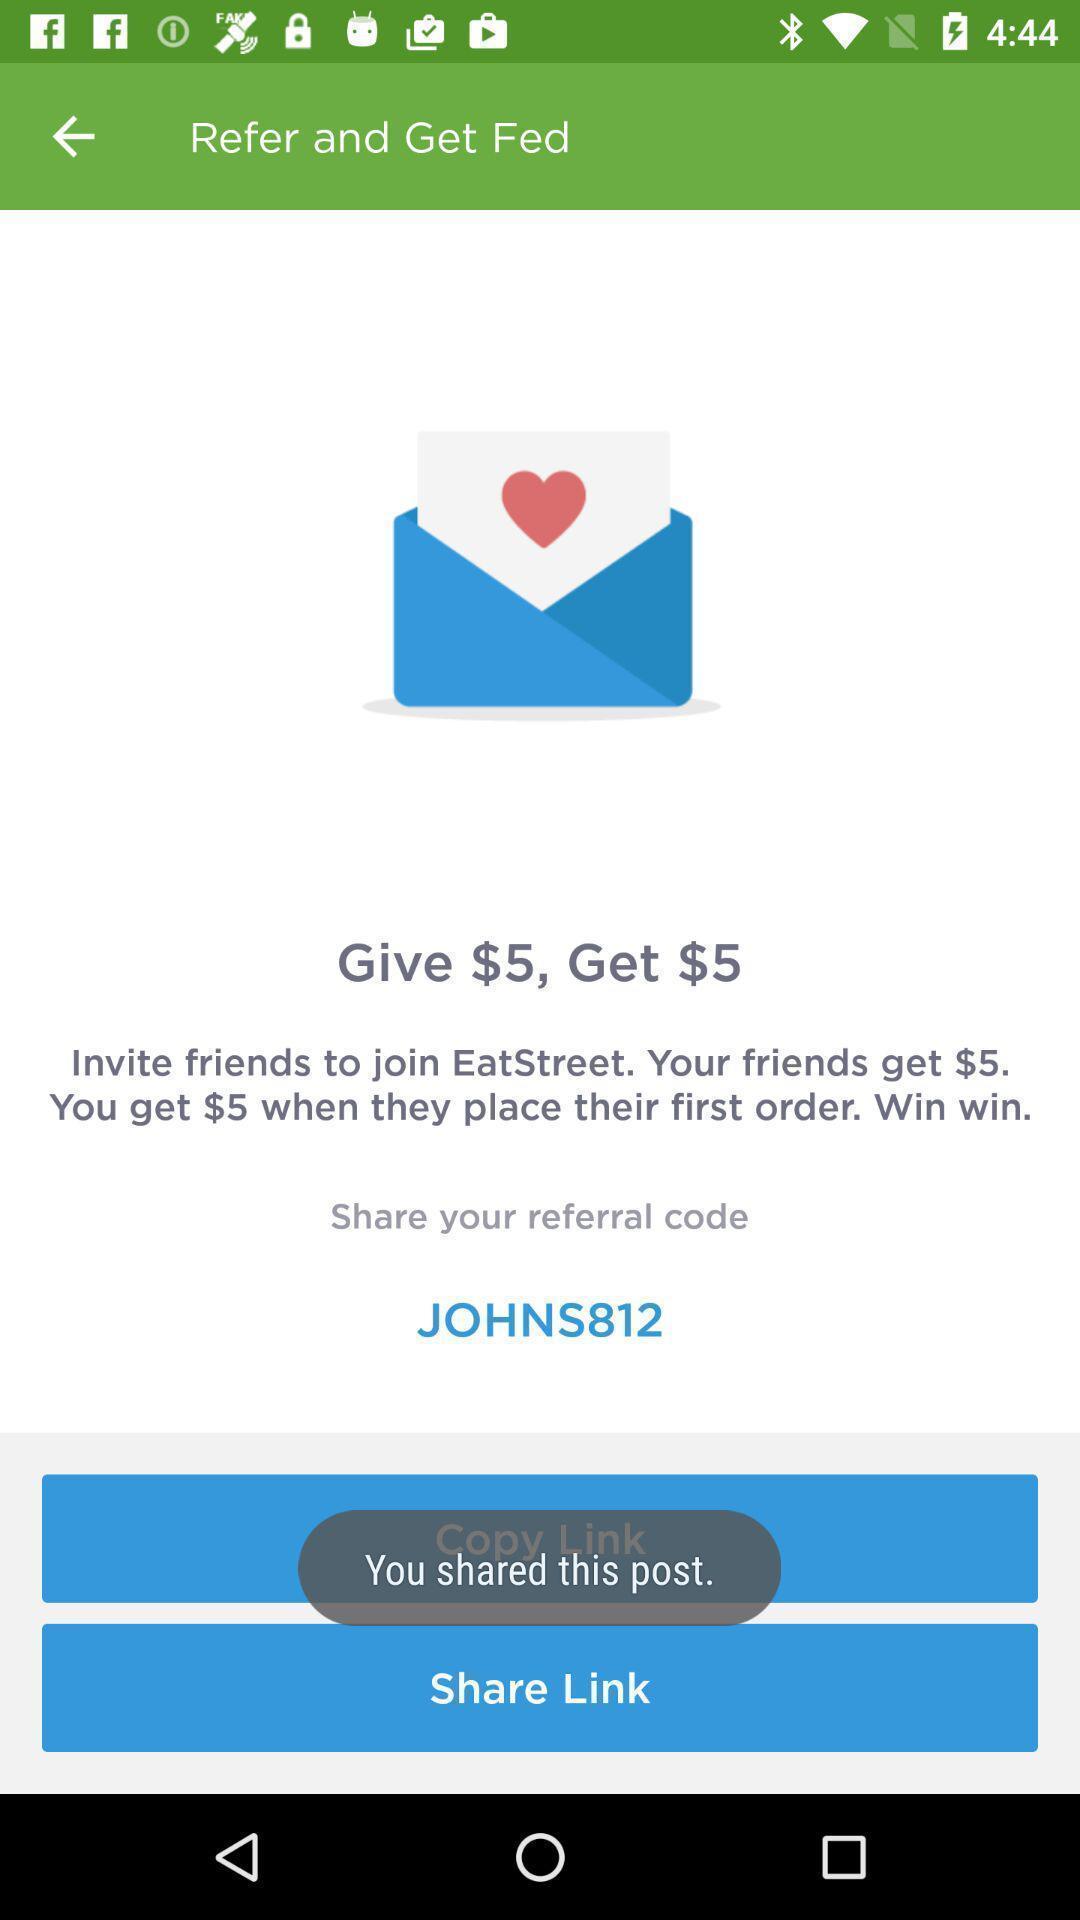Describe this image in words. Share page. 